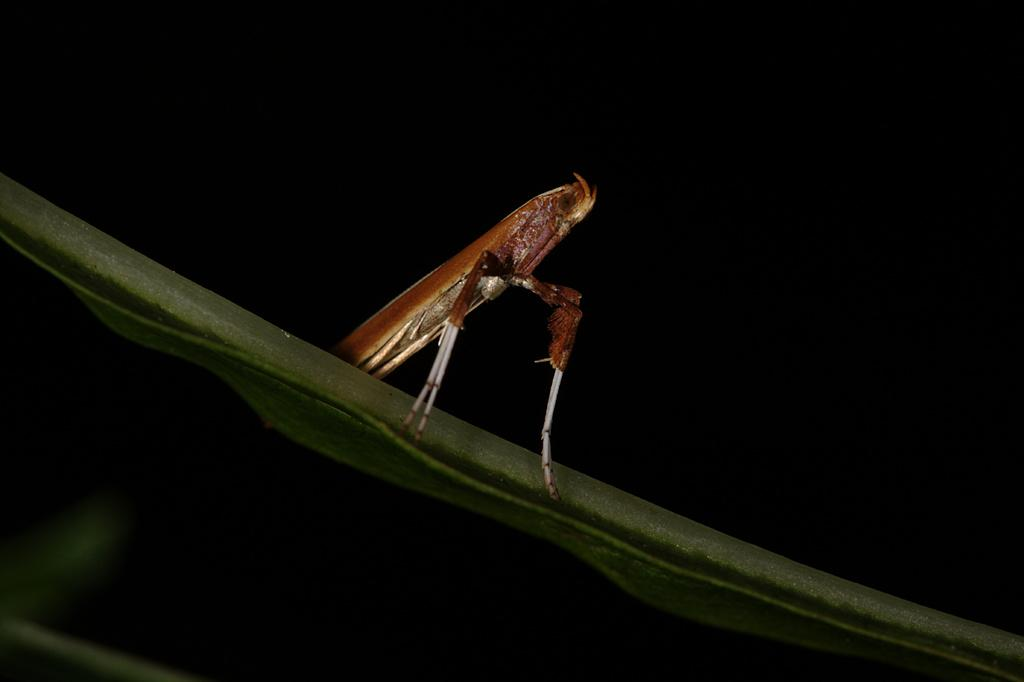What is present on the leaf in the image? There is an insect on a leaf in the image. What can be observed in the background of the image? The background of the image is dark. What type of noise is the scarecrow making in the image? There is no scarecrow present in the image, and therefore no noise can be attributed to it. 